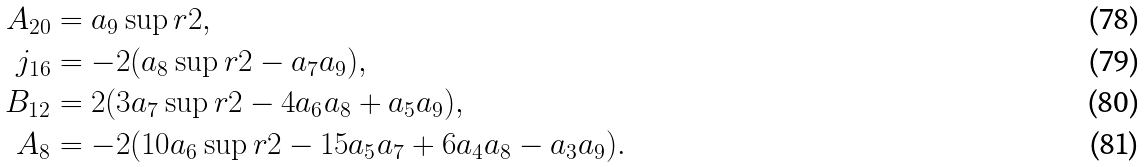<formula> <loc_0><loc_0><loc_500><loc_500>A _ { 2 0 } & = a _ { 9 } \sup r { 2 } , \\ j _ { 1 6 } & = - 2 ( a _ { 8 } \sup r { 2 } - a _ { 7 } a _ { 9 } ) , \\ B _ { 1 2 } & = 2 ( 3 a _ { 7 } \sup r { 2 } - 4 a _ { 6 } a _ { 8 } + a _ { 5 } a _ { 9 } ) , \\ A _ { 8 } & = - 2 ( 1 0 a _ { 6 } \sup r { 2 } - 1 5 a _ { 5 } a _ { 7 } + 6 a _ { 4 } a _ { 8 } - a _ { 3 } a _ { 9 } ) .</formula> 